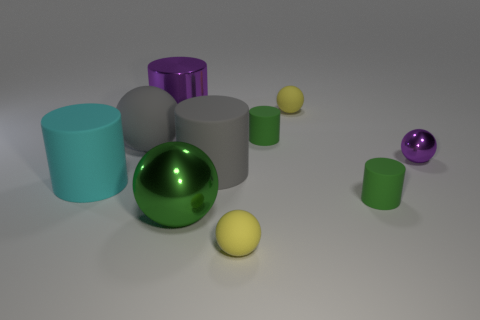The small ball that is behind the purple shiny cylinder behind the tiny shiny sphere is what color? The small ball in question appears to be yellow; however, upon careful examination of the image, there is no small ball behind the purple shiny cylinder. All the visible balls are either yellow or purple and are positioned in front of the cylinders. 